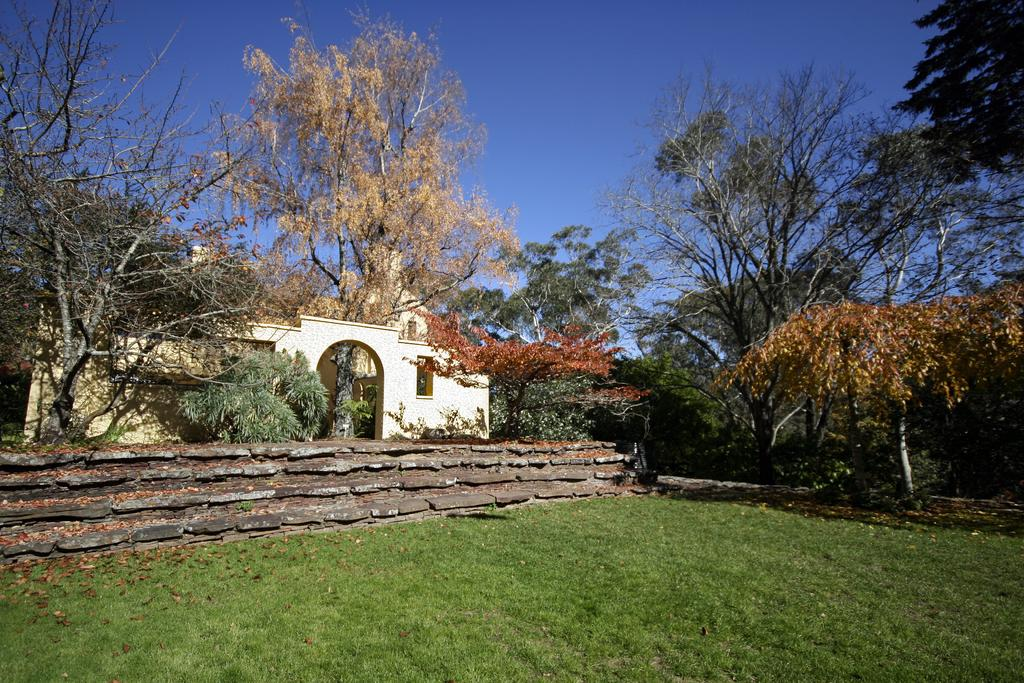What type of vegetation is present in the image? There is grass in the image. What type of structure can be seen in the image? There is a fence in the image. What other natural elements are visible in the image? There are trees in the image. What type of man-made structure is present in the image? There is a building in the image. What part of the natural environment is visible in the image? The sky is visible in the image. Based on the presence of the sky and the absence of artificial lighting, when do you think the image was taken? The image was likely taken during the day. What type of drain can be seen in the image? There is no drain present in the image. What type of teeth can be seen on the trees in the image? Trees do not have teeth, so this question is not applicable to the image. 